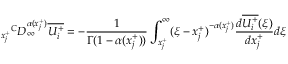Convert formula to latex. <formula><loc_0><loc_0><loc_500><loc_500>{ _ { x _ { j } ^ { + } } } ^ { C } D _ { \infty } ^ { \alpha ( x _ { j } ^ { + } ) } \overline { { U _ { i } ^ { + } } } = - \frac { 1 } { \Gamma ( 1 - \alpha ( x _ { j } ^ { + } ) ) } \int _ { x _ { j } ^ { + } } ^ { \infty } ( \xi - x _ { j } ^ { + } ) ^ { - \alpha ( x _ { j } ^ { + } ) } \frac { d \overline { { U _ { i } ^ { + } } } ( \xi ) } { d x _ { j } ^ { + } } d \xi</formula> 